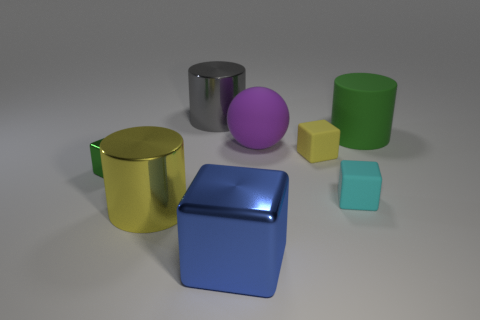Subtract 1 blocks. How many blocks are left? 3 Subtract all big shiny cubes. How many cubes are left? 3 Subtract all red cubes. Subtract all yellow cylinders. How many cubes are left? 4 Add 1 rubber objects. How many objects exist? 9 Subtract all cylinders. How many objects are left? 5 Subtract 0 cyan cylinders. How many objects are left? 8 Subtract all tiny rubber objects. Subtract all small matte blocks. How many objects are left? 4 Add 4 small cubes. How many small cubes are left? 7 Add 4 cyan cylinders. How many cyan cylinders exist? 4 